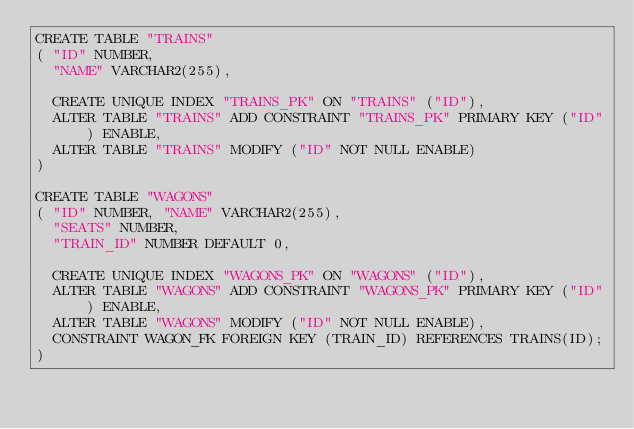Convert code to text. <code><loc_0><loc_0><loc_500><loc_500><_SQL_>CREATE TABLE "TRAINS" 
(	"ID" NUMBER, 
	"NAME" VARCHAR2(255),

	CREATE UNIQUE INDEX "TRAINS_PK" ON "TRAINS" ("ID"),
	ALTER TABLE "TRAINS" ADD CONSTRAINT "TRAINS_PK" PRIMARY KEY ("ID") ENABLE,
	ALTER TABLE "TRAINS" MODIFY ("ID" NOT NULL ENABLE)
)

CREATE TABLE "WAGONS" 
(	"ID" NUMBER, "NAME" VARCHAR2(255), 
	"SEATS" NUMBER, 
	"TRAIN_ID" NUMBER DEFAULT 0,

	CREATE UNIQUE INDEX "WAGONS_PK" ON "WAGONS" ("ID"),
	ALTER TABLE "WAGONS" ADD CONSTRAINT "WAGONS_PK" PRIMARY KEY ("ID") ENABLE,
	ALTER TABLE "WAGONS" MODIFY ("ID" NOT NULL ENABLE),
	CONSTRAINT WAGON_FK FOREIGN KEY (TRAIN_ID) REFERENCES TRAINS(ID);
)

</code> 